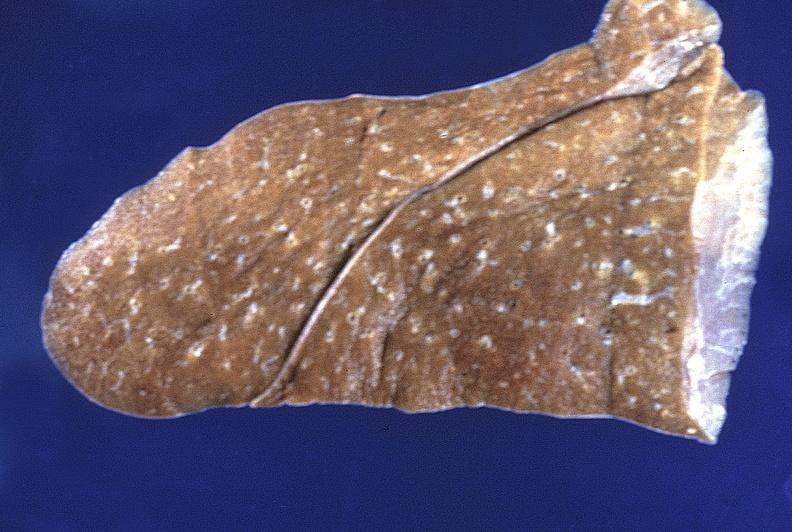does this image show normal lung?
Answer the question using a single word or phrase. Yes 